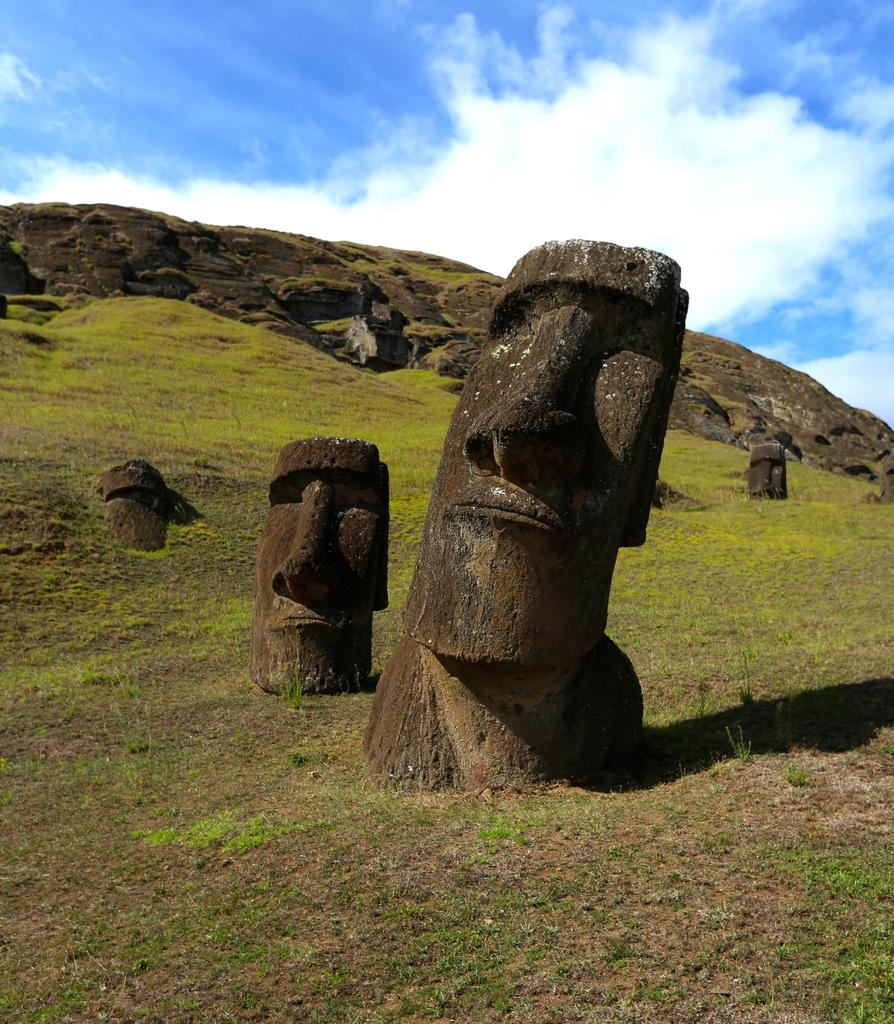What can be found on the ground in the image? There are sculptures on the ground in the image. What type of vegetation is present on the ground in the image? There is grass on the ground in the image. What geographical feature is visible in the image? There is a hill visible in the image. What is visible in the background of the image? The sky is visible in the background of the image. What can be seen in the sky in the background of the image? There are clouds in the sky in the background of the image. What type of ornament is hanging from the clouds in the image? There is no ornament hanging from the clouds in the image; the clouds are simply visible in the sky. Can you tell me how many bottles of wine are present in the image? There is no wine or bottles present in the image; it features sculptures, grass, a hill, and clouds. 